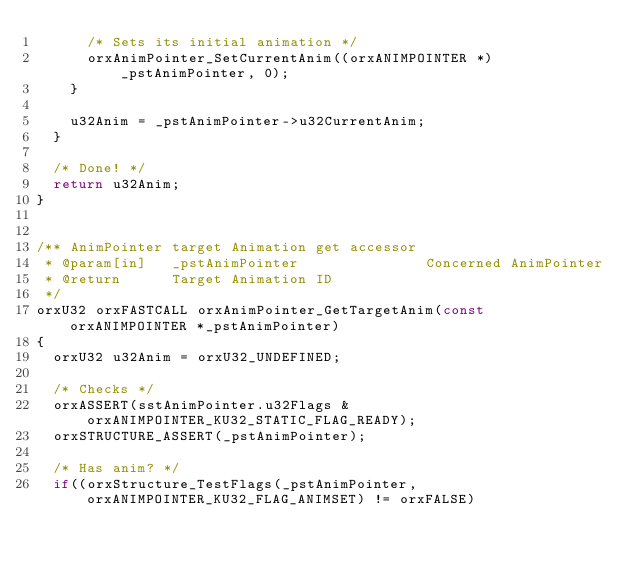Convert code to text. <code><loc_0><loc_0><loc_500><loc_500><_C_>      /* Sets its initial animation */
      orxAnimPointer_SetCurrentAnim((orxANIMPOINTER *)_pstAnimPointer, 0);
    }

    u32Anim = _pstAnimPointer->u32CurrentAnim;
  }

  /* Done! */
  return u32Anim;
}


/** AnimPointer target Animation get accessor
 * @param[in]   _pstAnimPointer               Concerned AnimPointer
 * @return      Target Animation ID
 */
orxU32 orxFASTCALL orxAnimPointer_GetTargetAnim(const orxANIMPOINTER *_pstAnimPointer)
{
  orxU32 u32Anim = orxU32_UNDEFINED;

  /* Checks */
  orxASSERT(sstAnimPointer.u32Flags & orxANIMPOINTER_KU32_STATIC_FLAG_READY);
  orxSTRUCTURE_ASSERT(_pstAnimPointer);

  /* Has anim? */
  if((orxStructure_TestFlags(_pstAnimPointer, orxANIMPOINTER_KU32_FLAG_ANIMSET) != orxFALSE)</code> 